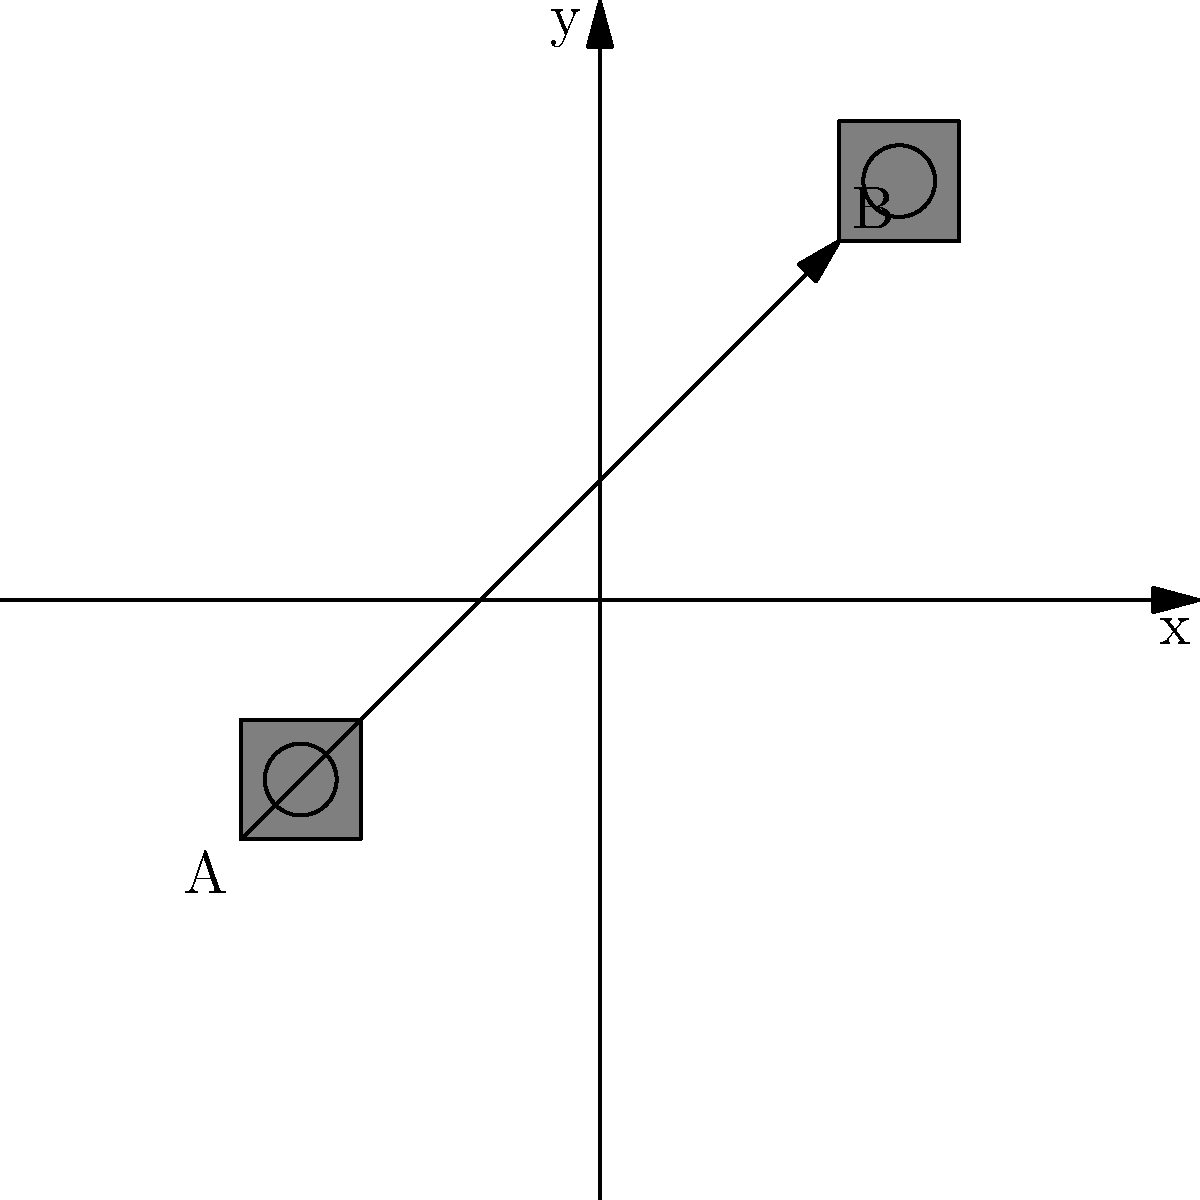As a film buff who prefers original movies, you're analyzing the movement of a camera on set. The camera, represented by the icon, is translated from point A $(-3, -2)$ to point B $(2, 3)$ on the coordinate plane. What is the translation vector that describes this movement? To find the translation vector, we need to determine the change in x and y coordinates from the initial position to the final position. Let's break it down step-by-step:

1. Initial position (point A): $(-3, -2)$
2. Final position (point B): $(2, 3)$

To calculate the translation vector:
3. Change in x-coordinate: $2 - (-3) = 2 + 3 = 5$
4. Change in y-coordinate: $3 - (-2) = 3 + 2 = 5$

The translation vector is the combination of these changes:
5. Translation vector = $\langle \text{change in x}, \text{change in y} \rangle = \langle 5, 5 \rangle$

This vector represents the horizontal and vertical distances the camera moved from its original position to its final position.
Answer: $\langle 5, 5 \rangle$ 